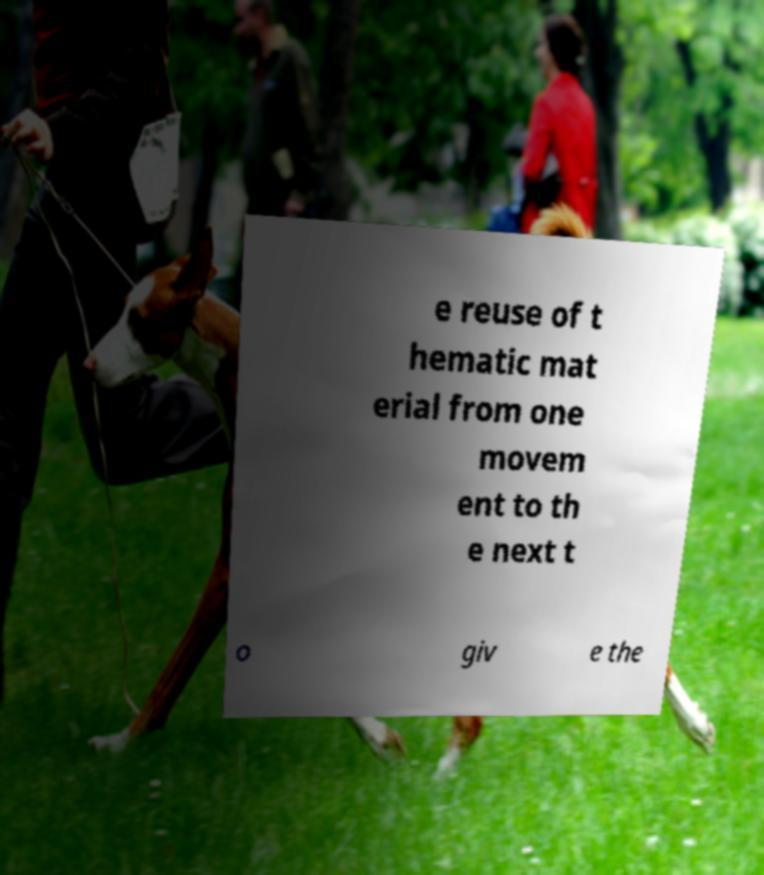Could you assist in decoding the text presented in this image and type it out clearly? e reuse of t hematic mat erial from one movem ent to th e next t o giv e the 